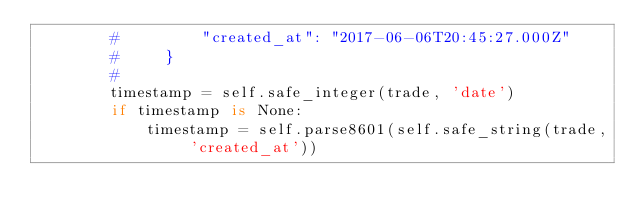Convert code to text. <code><loc_0><loc_0><loc_500><loc_500><_Python_>        #         "created_at": "2017-06-06T20:45:27.000Z"
        #     }
        #
        timestamp = self.safe_integer(trade, 'date')
        if timestamp is None:
            timestamp = self.parse8601(self.safe_string(trade, 'created_at'))</code> 